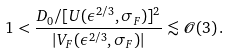Convert formula to latex. <formula><loc_0><loc_0><loc_500><loc_500>1 < \frac { D _ { 0 } / [ U ( \epsilon ^ { 2 / 3 } , \sigma _ { F } ) ] ^ { 2 } } { | V _ { F } ( \epsilon ^ { 2 / 3 } , \sigma _ { F } ) | } \lesssim { \mathcal { O } } ( 3 ) \, .</formula> 